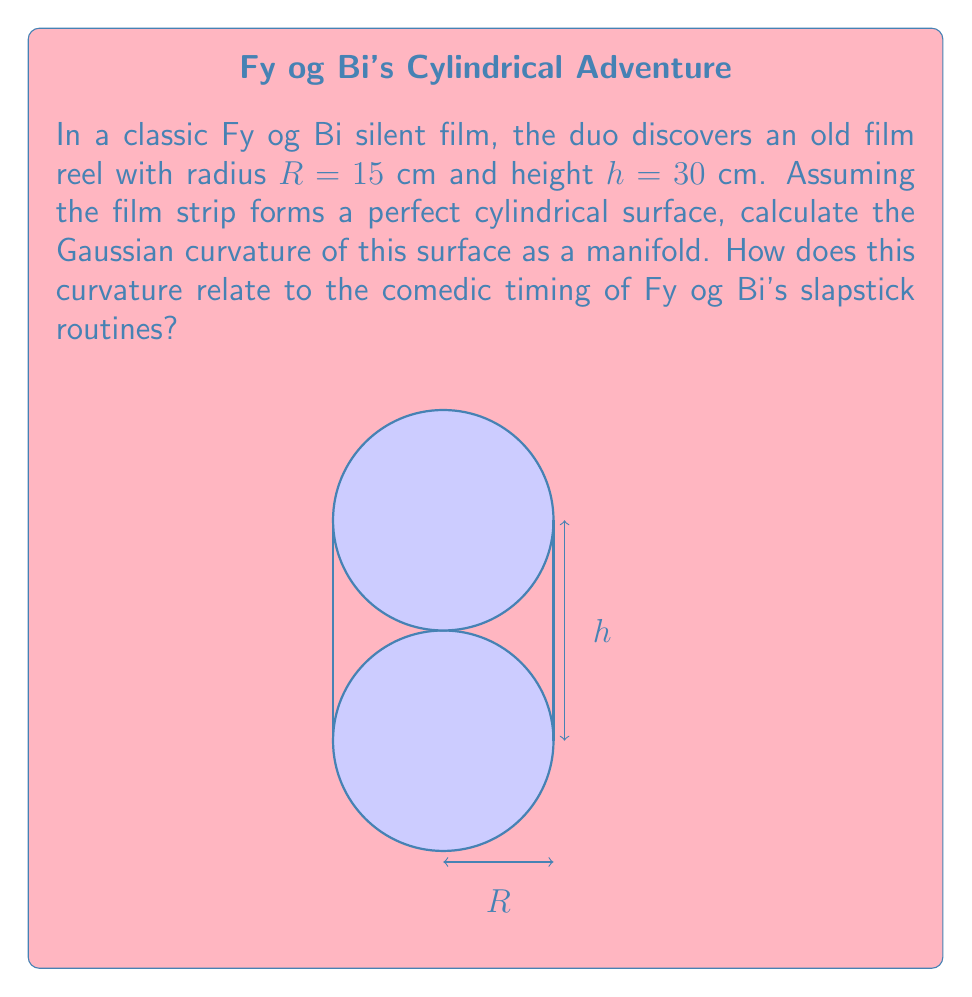Show me your answer to this math problem. Let's approach this step-by-step:

1) The film reel forms a cylindrical surface. For a cylinder, we need to calculate the principal curvatures.

2) A cylinder has two principal curvatures:
   - $k_1 = \frac{1}{R}$ (curvature in the circular direction)
   - $k_2 = 0$ (curvature along the height, which is a straight line)

3) The Gaussian curvature $K$ is defined as the product of the principal curvatures:

   $$K = k_1 \cdot k_2$$

4) Substituting our values:

   $$K = \frac{1}{R} \cdot 0 = 0$$

5) Therefore, the Gaussian curvature of the cylindrical film reel is 0, regardless of its radius or height.

6) This zero curvature relates to Fy og Bi's comedic timing in an interesting way. Just as the flat nature of the cylinder's surface allows for smooth, predictable motion when unwinding the film, the duo's impeccable timing in their slapstick routines creates a smooth flow of comedy, despite the apparent chaos of their actions.
Answer: $K = 0$ 